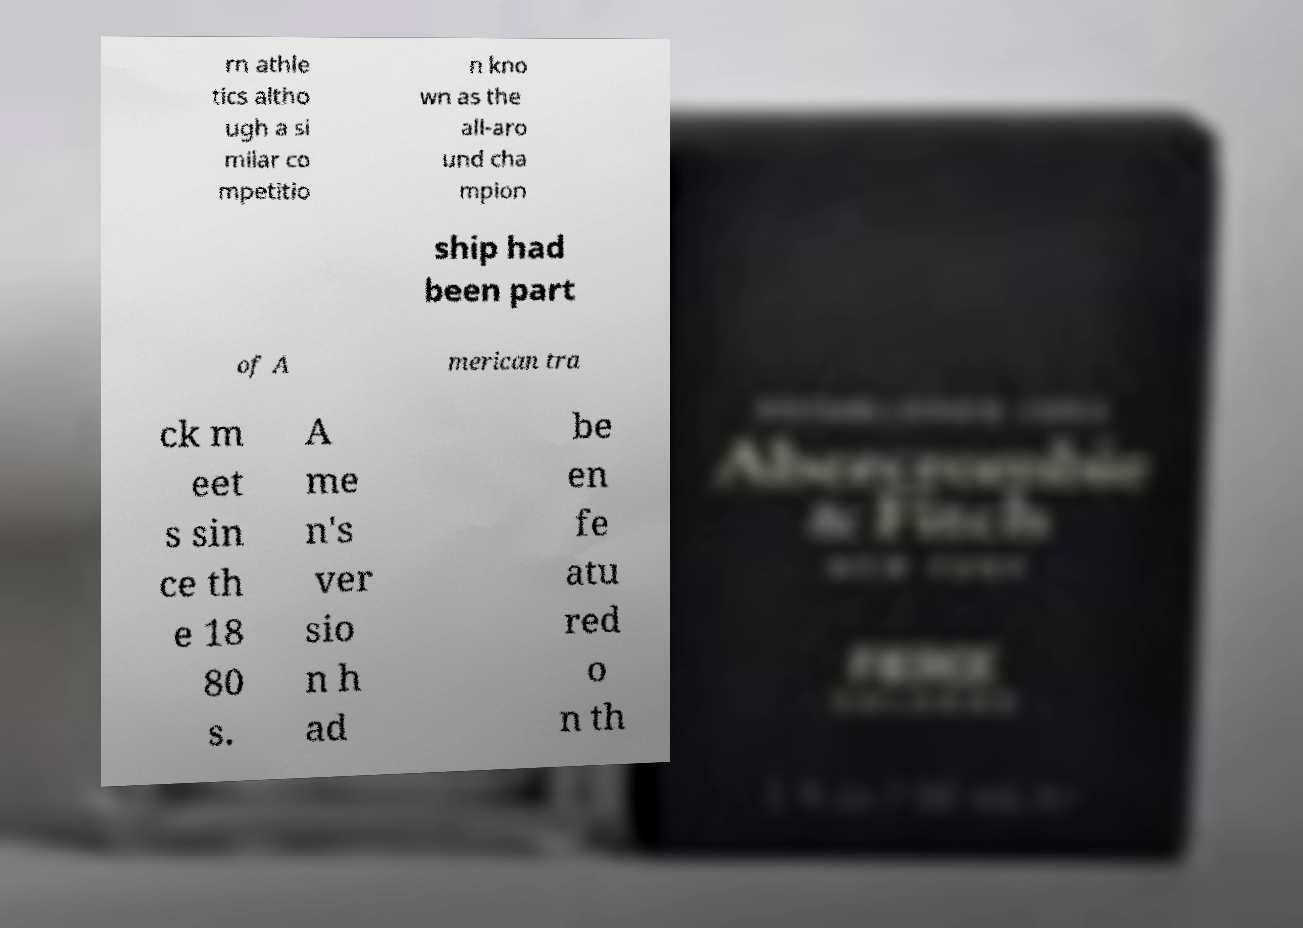Can you provide more details on what the text might be referring to? The text seems to be discussing the history of an athletic competition, probably alluding to an event known since the 1880s. Given the reference to 'track meets' and 'championship', it might focus on a significant athletic or sporting occasion from American history. 